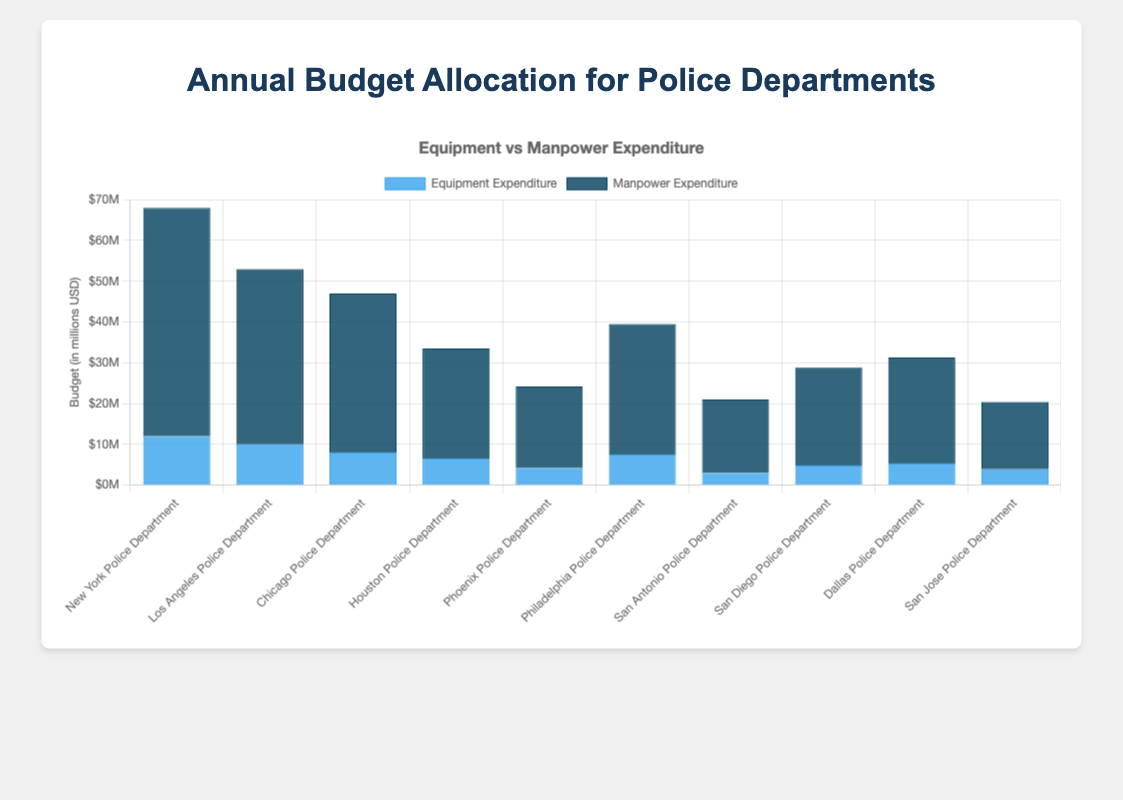Which police department has the highest equipment expenditure? By visually inspecting the bar chart, identify the tallest blue bar representing the equipment expenditure for the departments. The New York Police Department (NYPD) has the tallest blue bar.
Answer: New York Police Department What is the total yearly budget for Los Angeles Police Department? Sum the height of both the equipment and manpower expenditure bars for Los Angeles Police Department. Equipment expenditure is $10,000,000 and manpower expenditure is $43,000,000. Thus, the total is $10,000,000 + $43,000,000 = $53,000,000.
Answer: $53,000,000 Which department spends more on manpower: Chicago Police Department or Houston Police Department? Compare the height of the dark blue bars for the Chicago Police Department and Houston Police Department. Chicago has $39,000,000 while Houston has $27,000,000.
Answer: Chicago Police Department What is the average equipment expenditure across all police departments? Sum up all the equipment expenditures across all departments and divide by the number of departments. $(12,000,000 + 10,000,000 + 8,000,000 + 6,500,000 + 4,200,000 + 7,500,000 + 3,000,000 + 4,800,000 + 5,300,000 + 3,900,000) / 10 = $64,200,000 / 10 = $6,420,000
Answer: $6,420,000 How does the manpower expenditure of San Antonio Police Department compare to that of Philadelphia Police Department? Compare the height of the dark blue bars for San Antonio and Philadelphia. San Antonio expenditure is $18,000,000 and Philadelphia is $32,000,000.
Answer: San Antonio spends less Identify the department with the lowest total budget allocation. Visually inspecting the sum of the lengths of both blue and dark blue bars for each department, San Jose Police Department has the lowest budget at $3,900,000 (equipment) + $16,500,000 (manpower) = $20,400,000.
Answer: San Jose Police Department Which department has the closest manpower expenditure to the average manpower expenditure of all departments? First, calculate the average manpower expenditure: $(56,000,000 + 43,000,000 + 39,000,000 + 27,000,000 + 20,000,000 + 32,000,000 + 18,000,000 + 24,000,000 + 26,000,000 + 16,500,000) / 10 = $305,500,000 / 10 = $30,550,000. Compare each department's manpower expenditure to this average; Philadelphia Police Department at $32,000,000 is the closest.
Answer: Philadelphia Police Department What percentage of the New York Police Department's budget is allocated to equipment? Calculate the percentage by dividing the equipment expenditure by the total budget and multiplying by 100. $(12,000,000 / 68,000,000) * 100 ≈ 17.65%
Answer: 17.65% Which department spends the least on equipment? Visually identify the shortest blue bar in the chart, which represents the lowest equipment expenditure. San Antonio Police Department has the shortest blue bar at $3,000,000.
Answer: San Antonio Police Department What is the combined budget of police departments in California (Los Angeles, San Diego, San Jose)? Sum the total budgets of the Los Angeles, San Diego, and San Jose Police Departments. Los Angeles: $10,000,000 + $43,000,000, San Diego: $4,800,000 + $24,000,000, San Jose: $3,900,000 + $16,500,000. Total is $53,000,000 + $28,800,000 + $20,400,000 = $102,200,000.
Answer: $102,200,000 